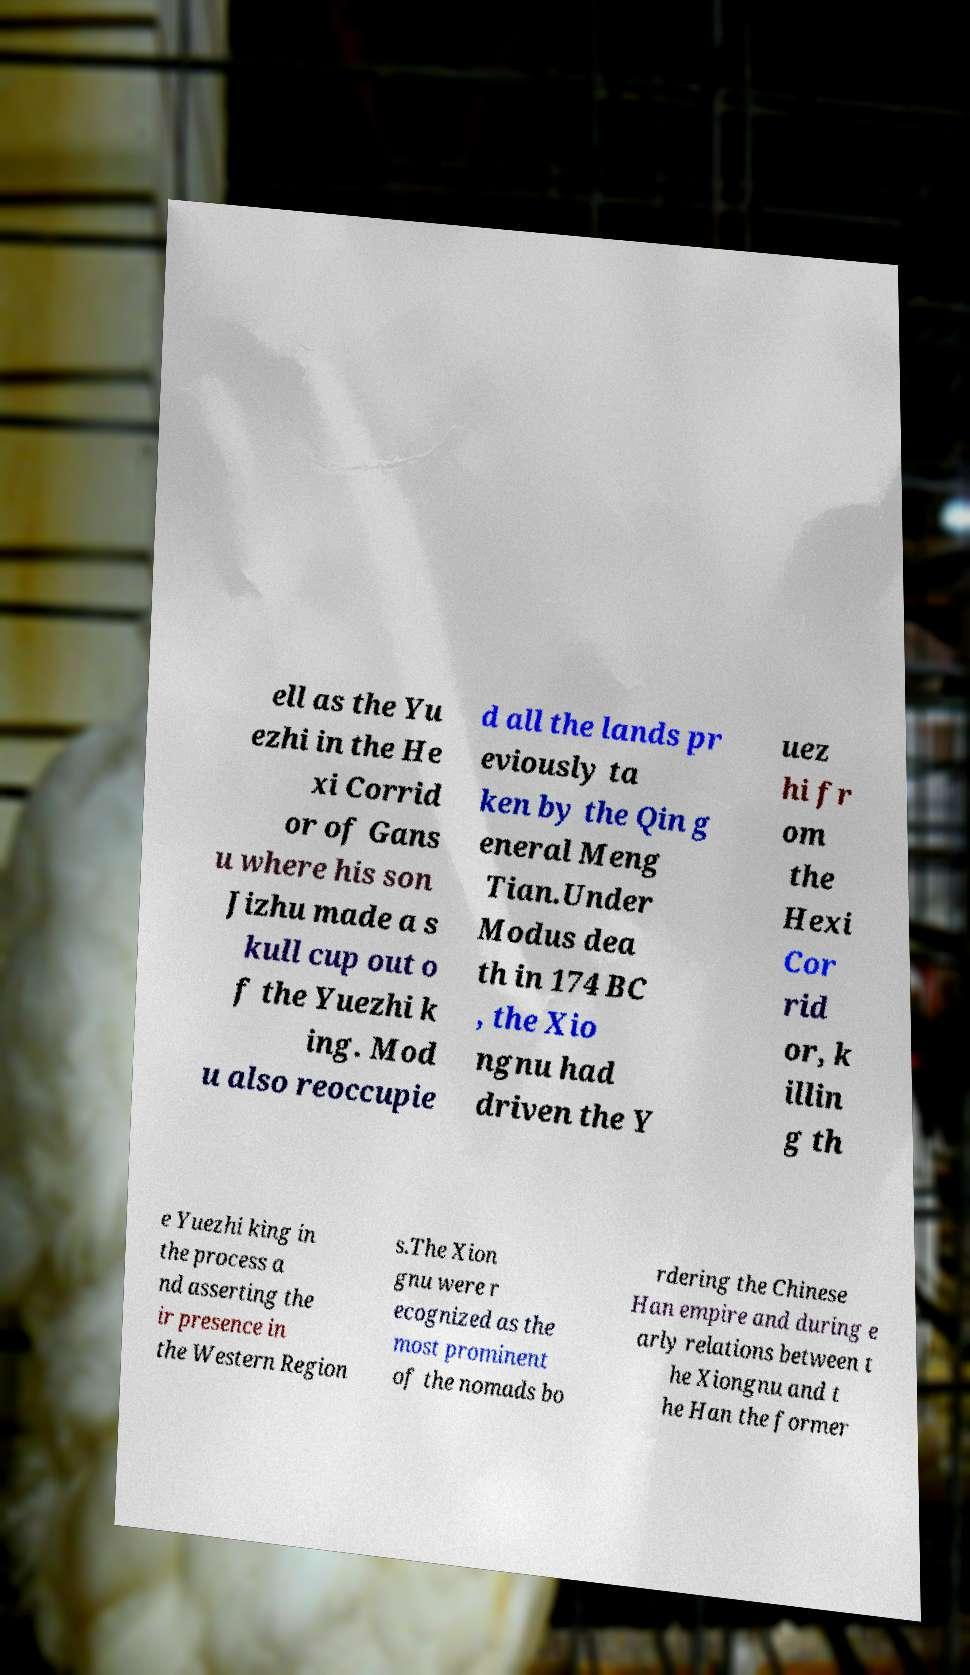What messages or text are displayed in this image? I need them in a readable, typed format. ell as the Yu ezhi in the He xi Corrid or of Gans u where his son Jizhu made a s kull cup out o f the Yuezhi k ing. Mod u also reoccupie d all the lands pr eviously ta ken by the Qin g eneral Meng Tian.Under Modus dea th in 174 BC , the Xio ngnu had driven the Y uez hi fr om the Hexi Cor rid or, k illin g th e Yuezhi king in the process a nd asserting the ir presence in the Western Region s.The Xion gnu were r ecognized as the most prominent of the nomads bo rdering the Chinese Han empire and during e arly relations between t he Xiongnu and t he Han the former 